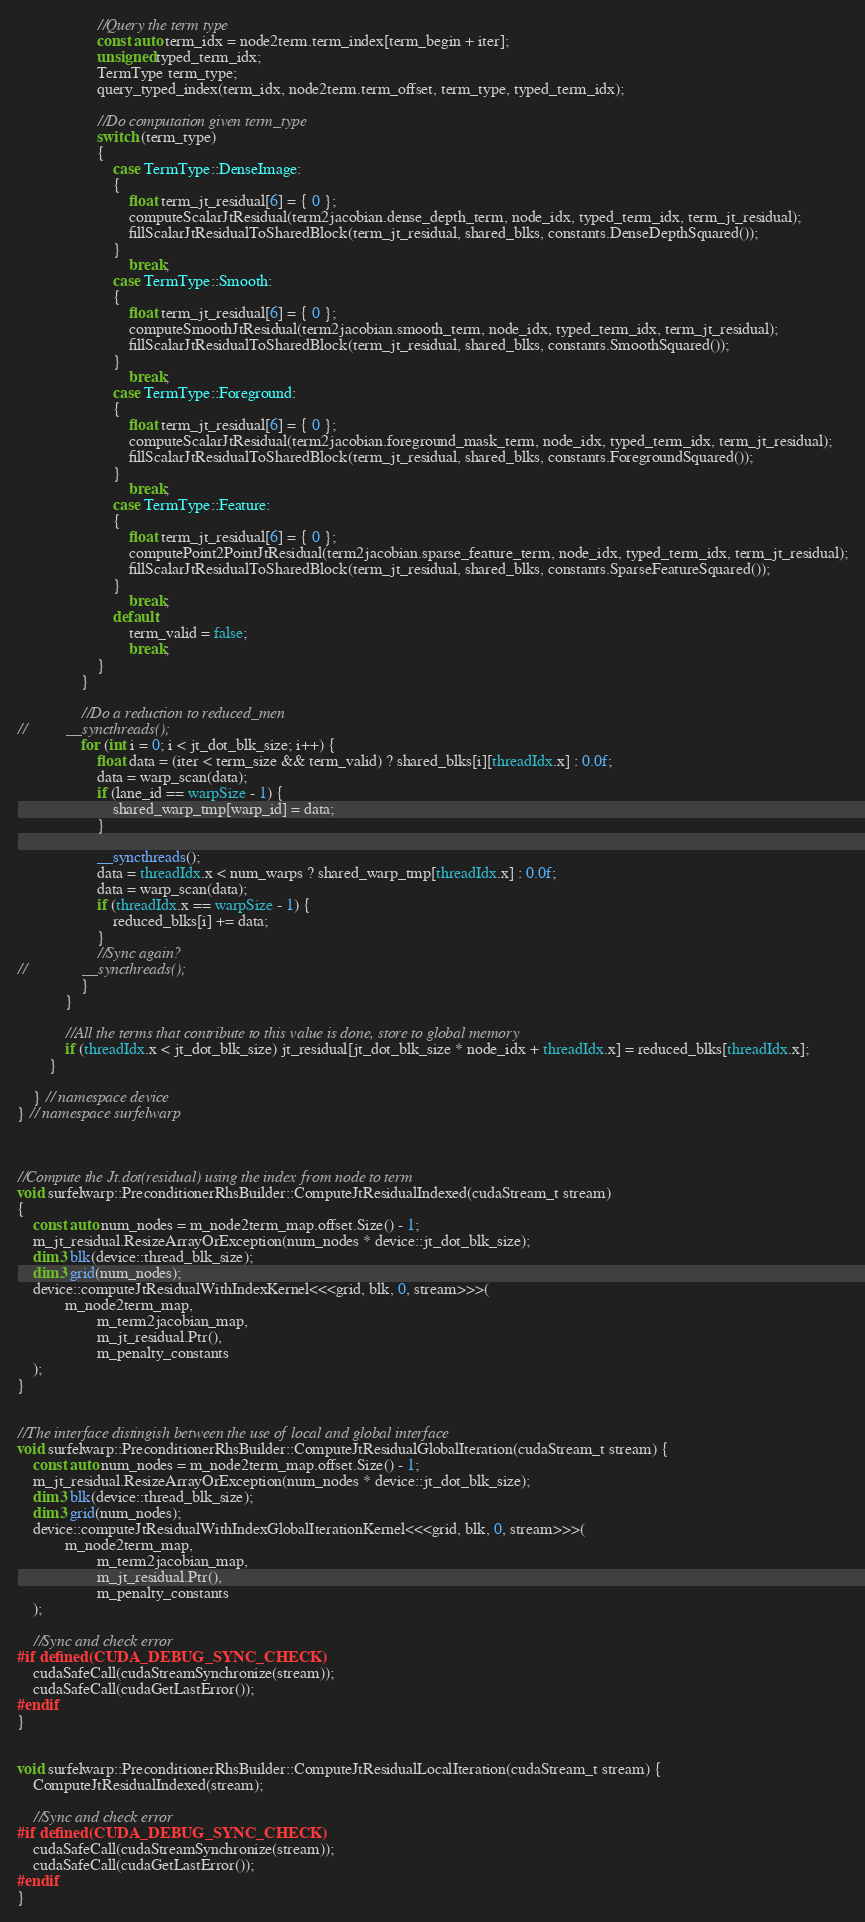<code> <loc_0><loc_0><loc_500><loc_500><_Cuda_>                    //Query the term type
                    const auto term_idx = node2term.term_index[term_begin + iter];
                    unsigned typed_term_idx;
                    TermType term_type;
                    query_typed_index(term_idx, node2term.term_offset, term_type, typed_term_idx);

                    //Do computation given term_type
                    switch (term_type)
                    {
                        case TermType::DenseImage:
                        {
                            float term_jt_residual[6] = { 0 };
                            computeScalarJtResidual(term2jacobian.dense_depth_term, node_idx, typed_term_idx, term_jt_residual);
                            fillScalarJtResidualToSharedBlock(term_jt_residual, shared_blks, constants.DenseDepthSquared());
                        }
                            break;
                        case TermType::Smooth:
                        {
                            float term_jt_residual[6] = { 0 };
                            computeSmoothJtResidual(term2jacobian.smooth_term, node_idx, typed_term_idx, term_jt_residual);
                            fillScalarJtResidualToSharedBlock(term_jt_residual, shared_blks, constants.SmoothSquared());
                        }
                            break;
                        case TermType::Foreground:
                        {
                            float term_jt_residual[6] = { 0 };
                            computeScalarJtResidual(term2jacobian.foreground_mask_term, node_idx, typed_term_idx, term_jt_residual);
                            fillScalarJtResidualToSharedBlock(term_jt_residual, shared_blks, constants.ForegroundSquared());
                        }
                            break;
                        case TermType::Feature:
                        {
                            float term_jt_residual[6] = { 0 };
                            computePoint2PointJtResidual(term2jacobian.sparse_feature_term, node_idx, typed_term_idx, term_jt_residual);
                            fillScalarJtResidualToSharedBlock(term_jt_residual, shared_blks, constants.SparseFeatureSquared());
                        }
                            break;
                        default:
                            term_valid = false;
                            break;
                    }
                }

                //Do a reduction to reduced_men
//			__syncthreads();
                for (int i = 0; i < jt_dot_blk_size; i++) {
                    float data = (iter < term_size && term_valid) ? shared_blks[i][threadIdx.x] : 0.0f;
                    data = warp_scan(data);
                    if (lane_id == warpSize - 1) {
                        shared_warp_tmp[warp_id] = data;
                    }

                    __syncthreads();
                    data = threadIdx.x < num_warps ? shared_warp_tmp[threadIdx.x] : 0.0f;
                    data = warp_scan(data);
                    if (threadIdx.x == warpSize - 1) {
                        reduced_blks[i] += data;
                    }
                    //Sync again?
//				__syncthreads();
                }
            }

            //All the terms that contribute to this value is done, store to global memory
            if (threadIdx.x < jt_dot_blk_size) jt_residual[jt_dot_blk_size * node_idx + threadIdx.x] = reduced_blks[threadIdx.x];
        }

    } // namespace device
} // namespace surfelwarp



//Compute the Jt.dot(residual) using the index from node to term
void surfelwarp::PreconditionerRhsBuilder::ComputeJtResidualIndexed(cudaStream_t stream)
{
    const auto num_nodes = m_node2term_map.offset.Size() - 1;
    m_jt_residual.ResizeArrayOrException(num_nodes * device::jt_dot_blk_size);
    dim3 blk(device::thread_blk_size);
    dim3 grid(num_nodes);
    device::computeJtResidualWithIndexKernel<<<grid, blk, 0, stream>>>(
            m_node2term_map,
                    m_term2jacobian_map,
                    m_jt_residual.Ptr(),
                    m_penalty_constants
    );
}


//The interface distingish between the use of local and global interface
void surfelwarp::PreconditionerRhsBuilder::ComputeJtResidualGlobalIteration(cudaStream_t stream) {
    const auto num_nodes = m_node2term_map.offset.Size() - 1;
    m_jt_residual.ResizeArrayOrException(num_nodes * device::jt_dot_blk_size);
    dim3 blk(device::thread_blk_size);
    dim3 grid(num_nodes);
    device::computeJtResidualWithIndexGlobalIterationKernel<<<grid, blk, 0, stream>>>(
            m_node2term_map,
                    m_term2jacobian_map,
                    m_jt_residual.Ptr(),
                    m_penalty_constants
    );

    //Sync and check error
#if defined(CUDA_DEBUG_SYNC_CHECK)
    cudaSafeCall(cudaStreamSynchronize(stream));
	cudaSafeCall(cudaGetLastError());
#endif
}


void surfelwarp::PreconditionerRhsBuilder::ComputeJtResidualLocalIteration(cudaStream_t stream) {
    ComputeJtResidualIndexed(stream);

    //Sync and check error
#if defined(CUDA_DEBUG_SYNC_CHECK)
    cudaSafeCall(cudaStreamSynchronize(stream));
	cudaSafeCall(cudaGetLastError());
#endif
}
</code> 